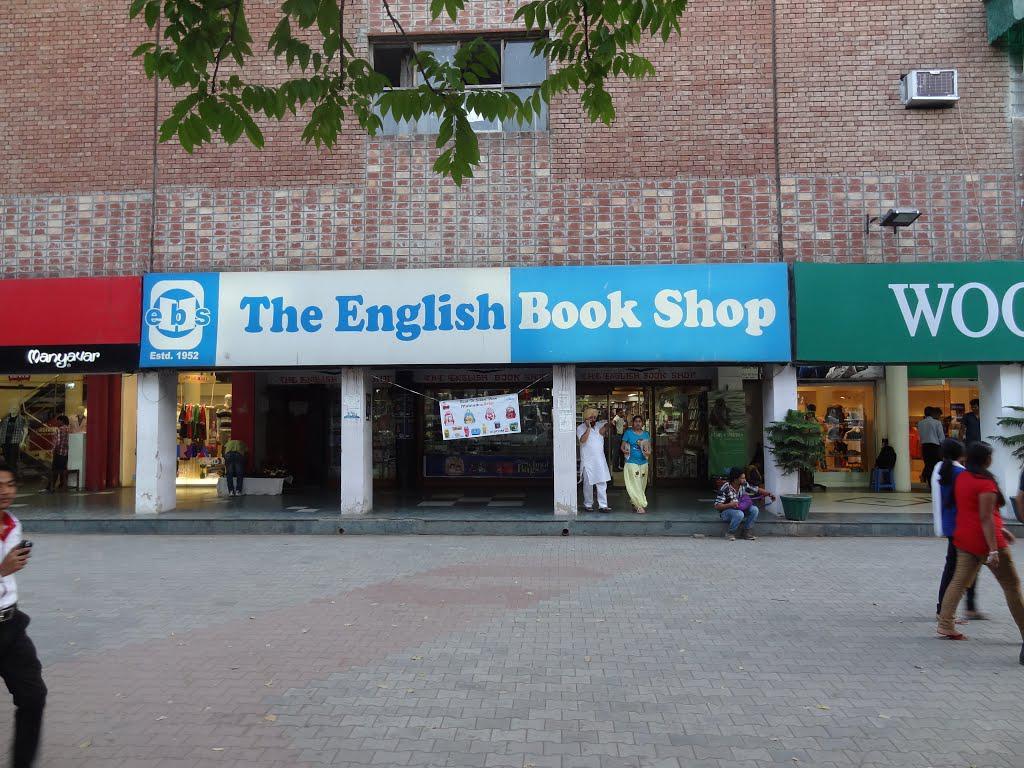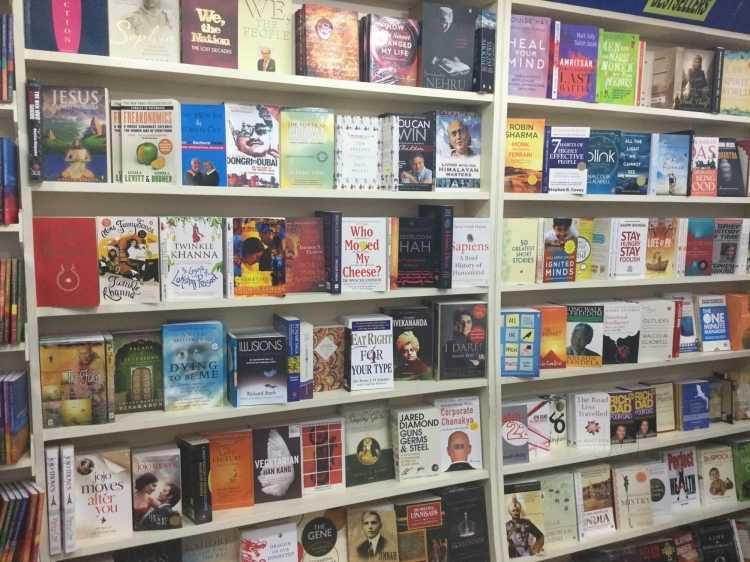The first image is the image on the left, the second image is the image on the right. Analyze the images presented: Is the assertion "People are standing in a bookstore." valid? Answer yes or no. No. The first image is the image on the left, the second image is the image on the right. Considering the images on both sides, is "Exactly one person, a standing woman, can be seen inside of a shop lined with bookshelves." valid? Answer yes or no. No. 